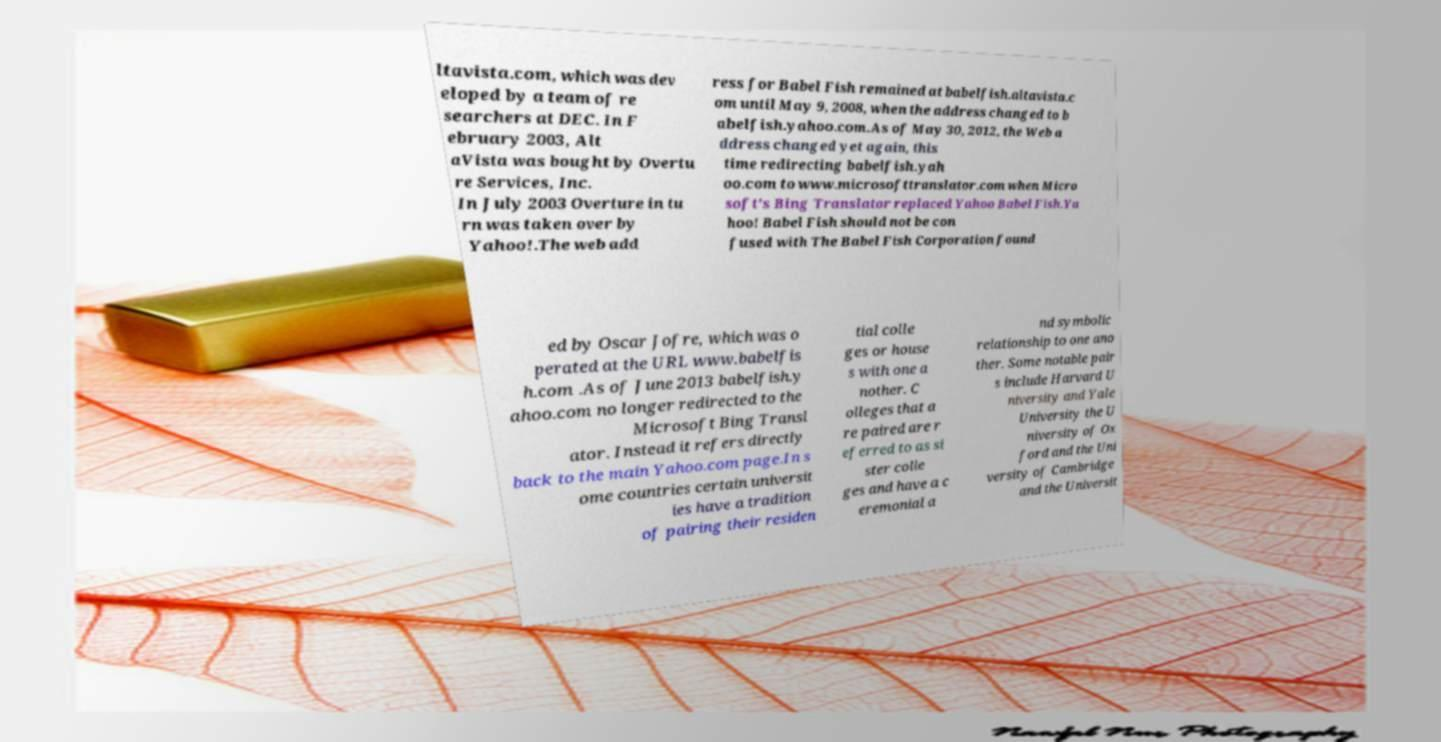Can you read and provide the text displayed in the image?This photo seems to have some interesting text. Can you extract and type it out for me? ltavista.com, which was dev eloped by a team of re searchers at DEC. In F ebruary 2003, Alt aVista was bought by Overtu re Services, Inc. In July 2003 Overture in tu rn was taken over by Yahoo!.The web add ress for Babel Fish remained at babelfish.altavista.c om until May 9, 2008, when the address changed to b abelfish.yahoo.com.As of May 30, 2012, the Web a ddress changed yet again, this time redirecting babelfish.yah oo.com to www.microsofttranslator.com when Micro soft's Bing Translator replaced Yahoo Babel Fish.Ya hoo! Babel Fish should not be con fused with The Babel Fish Corporation found ed by Oscar Jofre, which was o perated at the URL www.babelfis h.com .As of June 2013 babelfish.y ahoo.com no longer redirected to the Microsoft Bing Transl ator. Instead it refers directly back to the main Yahoo.com page.In s ome countries certain universit ies have a tradition of pairing their residen tial colle ges or house s with one a nother. C olleges that a re paired are r eferred to as si ster colle ges and have a c eremonial a nd symbolic relationship to one ano ther. Some notable pair s include Harvard U niversity and Yale University the U niversity of Ox ford and the Uni versity of Cambridge and the Universit 